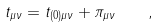Convert formula to latex. <formula><loc_0><loc_0><loc_500><loc_500>t _ { \mu \nu } = t _ { ( 0 ) \mu \nu } + \pi _ { \mu \nu } \quad ,</formula> 